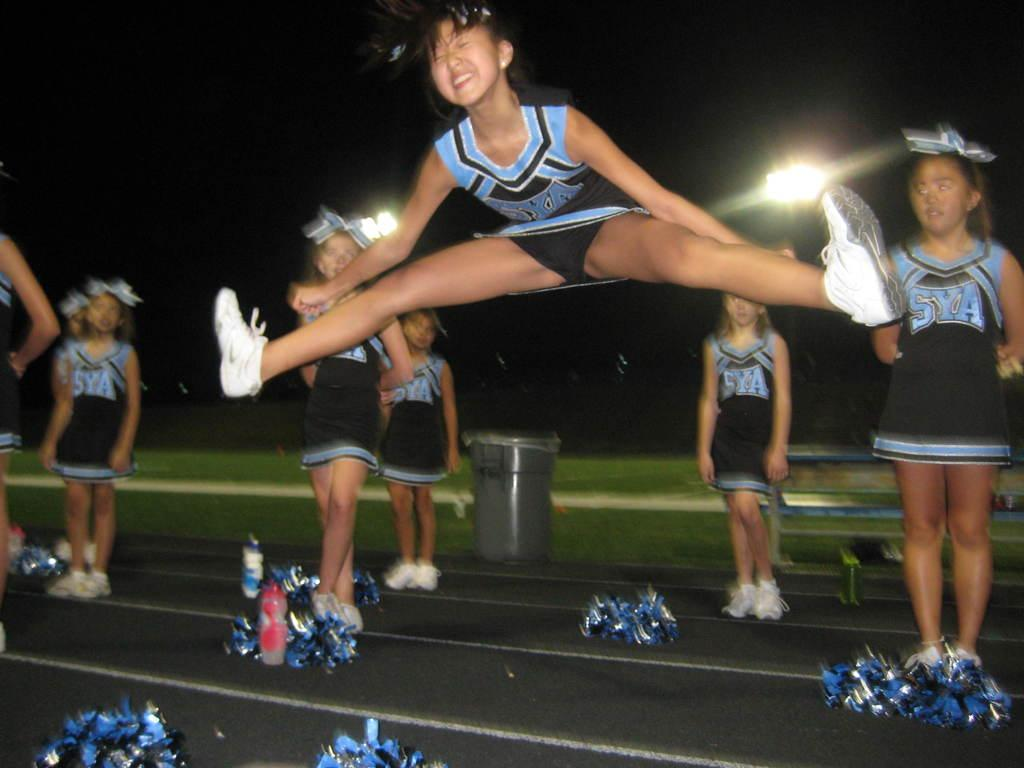<image>
Relay a brief, clear account of the picture shown. A SYA cheerleader does an air split in front of her squad. 